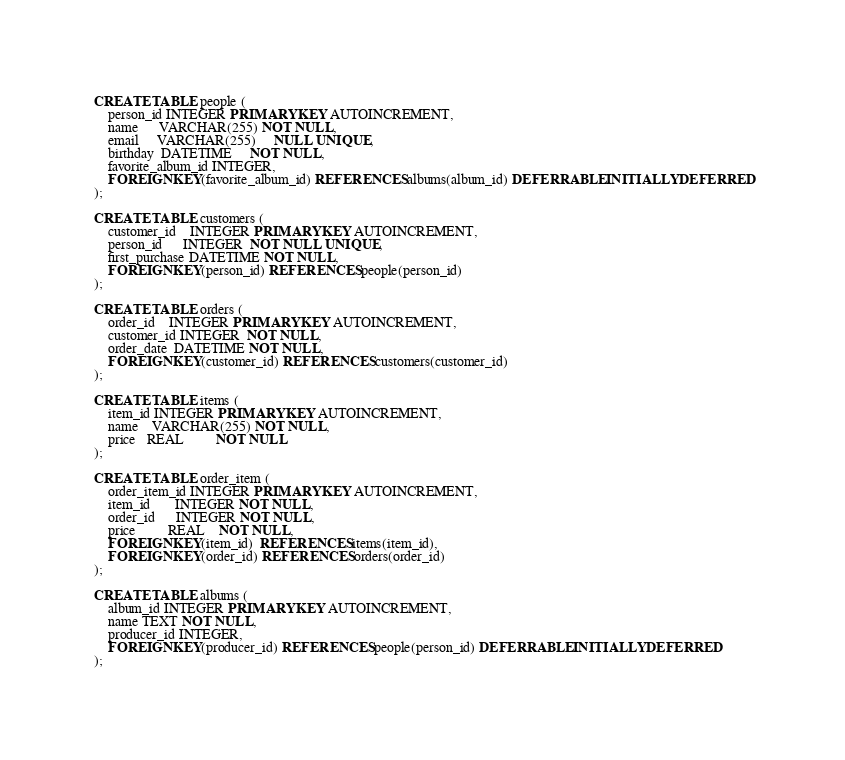<code> <loc_0><loc_0><loc_500><loc_500><_SQL_>CREATE TABLE people (
    person_id INTEGER PRIMARY KEY AUTOINCREMENT,
    name      VARCHAR(255) NOT NULL,
    email     VARCHAR(255)     NULL UNIQUE,
    birthday  DATETIME     NOT NULL,
    favorite_album_id INTEGER,
    FOREIGN KEY(favorite_album_id) REFERENCES albums(album_id) DEFERRABLE INITIALLY DEFERRED
);

CREATE TABLE customers (
    customer_id    INTEGER PRIMARY KEY AUTOINCREMENT,
    person_id      INTEGER  NOT NULL UNIQUE,
    first_purchase DATETIME NOT NULL,
    FOREIGN KEY(person_id) REFERENCES people(person_id)
);

CREATE TABLE orders (
    order_id    INTEGER PRIMARY KEY AUTOINCREMENT,
    customer_id INTEGER  NOT NULL,
    order_date  DATETIME NOT NULL,
    FOREIGN KEY(customer_id) REFERENCES customers(customer_id)
);

CREATE TABLE items (
    item_id INTEGER PRIMARY KEY AUTOINCREMENT,
    name    VARCHAR(255) NOT NULL,
    price   REAL         NOT NULL
);

CREATE TABLE order_item (
    order_item_id INTEGER PRIMARY KEY AUTOINCREMENT,
    item_id       INTEGER NOT NULL,
    order_id      INTEGER NOT NULL,
    price         REAL    NOT NULL,
    FOREIGN KEY(item_id)  REFERENCES items(item_id),
    FOREIGN KEY(order_id) REFERENCES orders(order_id)
);

CREATE TABLE albums (
    album_id INTEGER PRIMARY KEY AUTOINCREMENT,
    name TEXT NOT NULL,
    producer_id INTEGER,
    FOREIGN KEY(producer_id) REFERENCES people(person_id) DEFERRABLE INITIALLY DEFERRED
);
</code> 